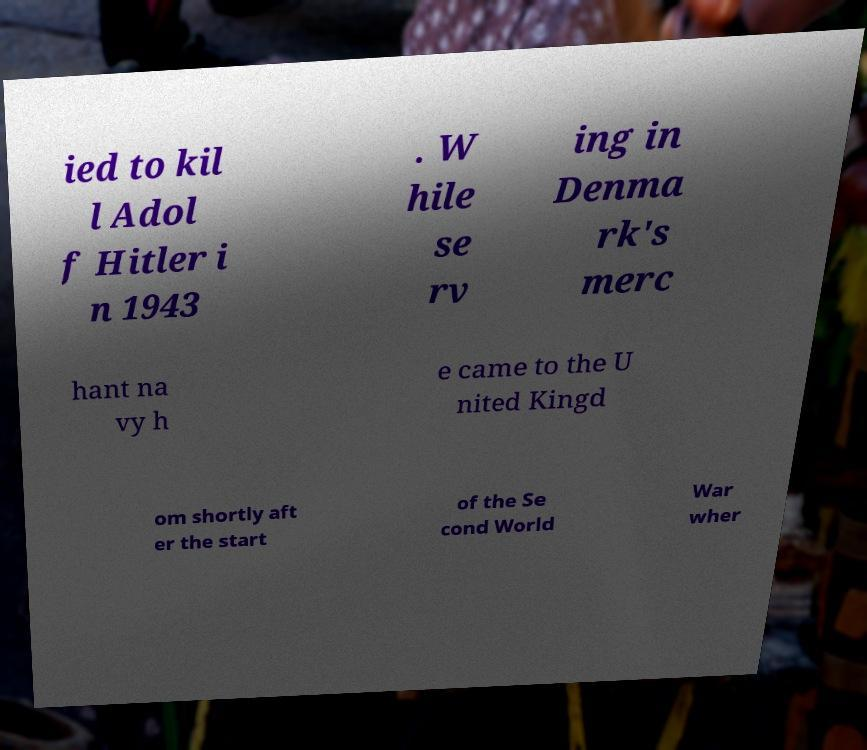Could you assist in decoding the text presented in this image and type it out clearly? ied to kil l Adol f Hitler i n 1943 . W hile se rv ing in Denma rk's merc hant na vy h e came to the U nited Kingd om shortly aft er the start of the Se cond World War wher 